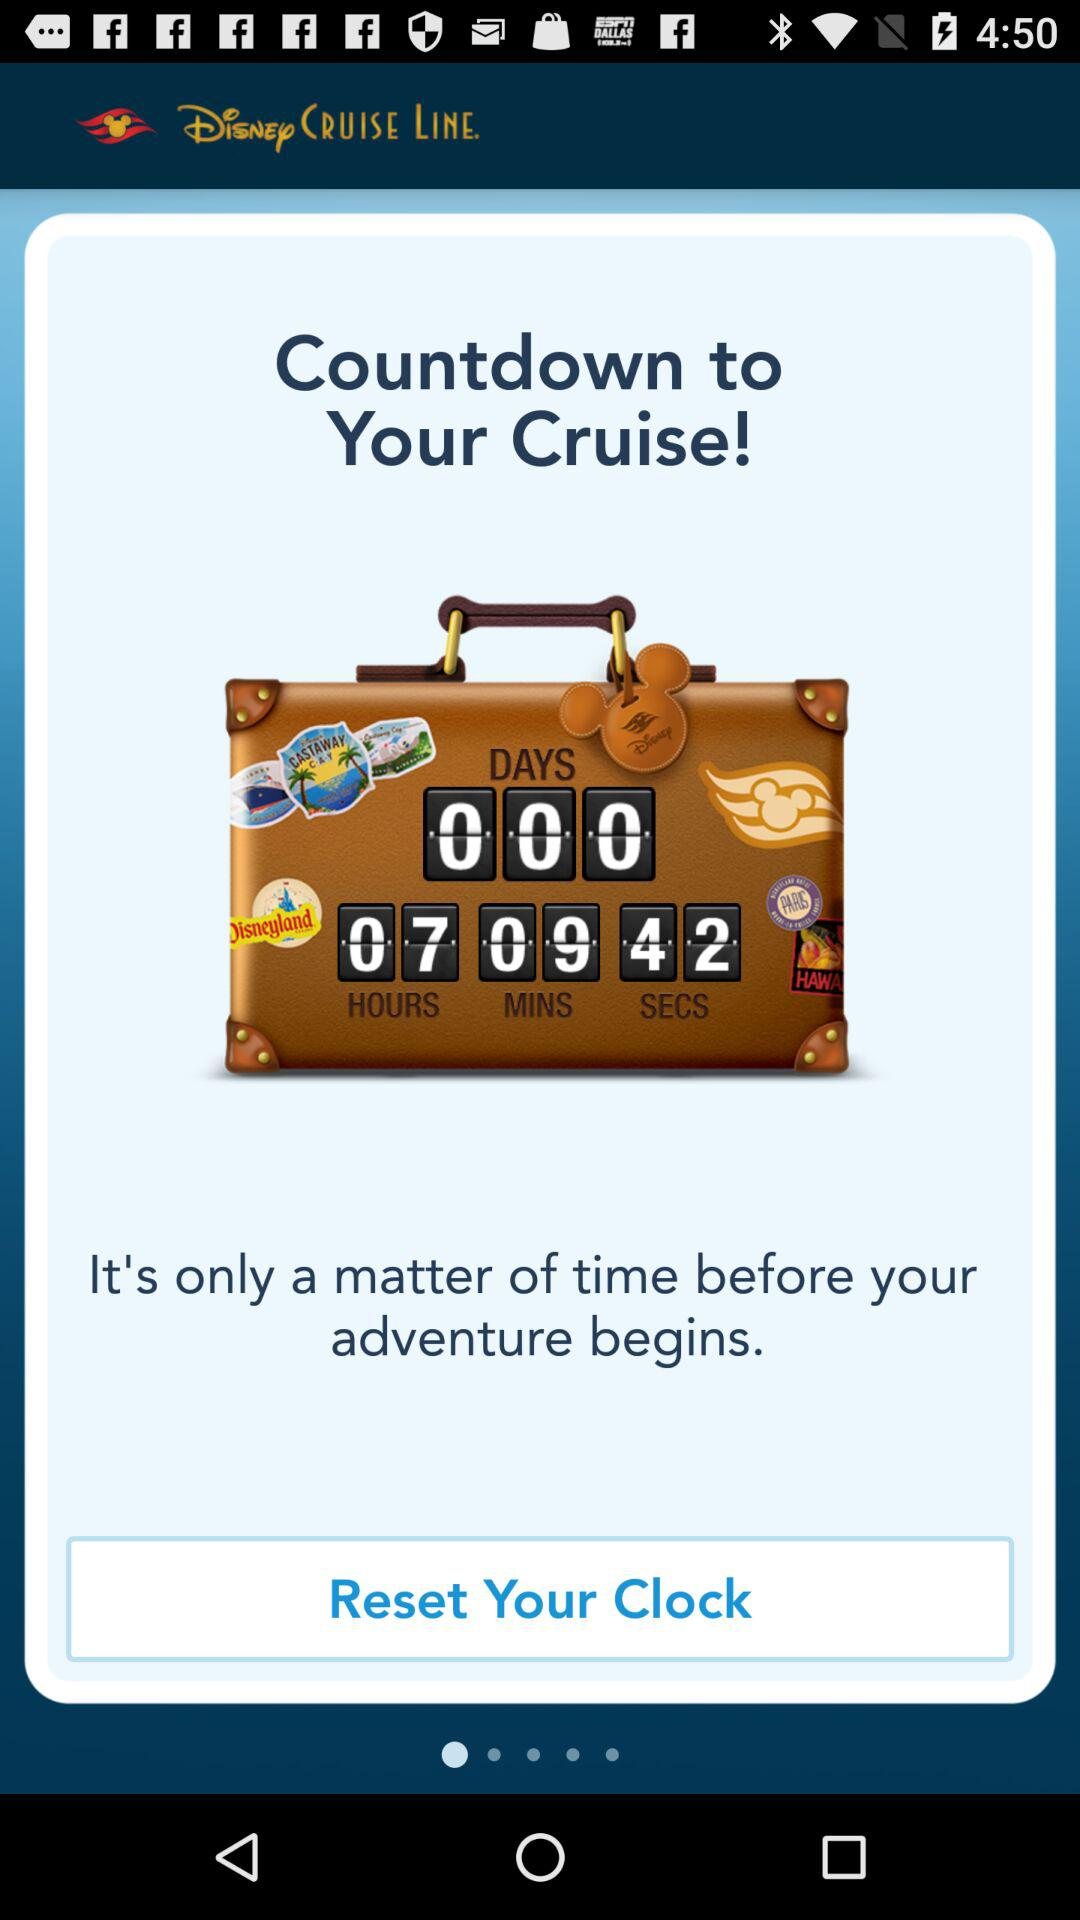What can we expect as onboard entertainment during the Disney cruise? Expect a variety of enchanting entertainment options on your Disney cruise, including themed shows, character meet-and-greets, and deck parties, all uniquely crafted to ensure an unforgettable experience for guests of all ages. 